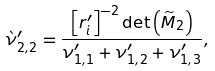<formula> <loc_0><loc_0><loc_500><loc_500>\grave { \nu } ^ { \prime } _ { 2 , 2 } & = \frac { \left [ r ^ { \prime } _ { i } \right ] ^ { - 2 } \det \left ( \widetilde { M } _ { 2 } \right ) } { \nu ^ { \prime } _ { 1 , 1 } + \nu ^ { \prime } _ { 1 , 2 } + \nu ^ { \prime } _ { 1 , 3 } } ,</formula> 